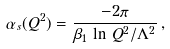Convert formula to latex. <formula><loc_0><loc_0><loc_500><loc_500>\alpha _ { s } ( Q ^ { 2 } ) = \frac { - 2 \pi } { \beta _ { 1 } \, \ln \, Q ^ { 2 } / \Lambda ^ { 2 } } \, ,</formula> 